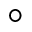<formula> <loc_0><loc_0><loc_500><loc_500>^ { \circ }</formula> 